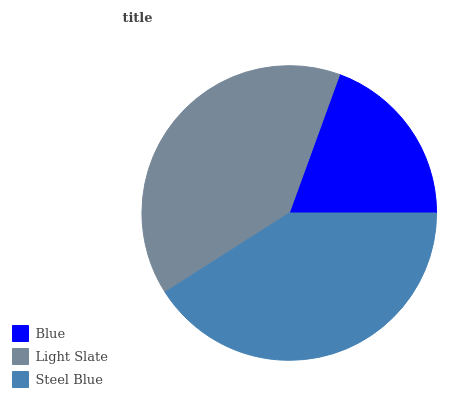Is Blue the minimum?
Answer yes or no. Yes. Is Steel Blue the maximum?
Answer yes or no. Yes. Is Light Slate the minimum?
Answer yes or no. No. Is Light Slate the maximum?
Answer yes or no. No. Is Light Slate greater than Blue?
Answer yes or no. Yes. Is Blue less than Light Slate?
Answer yes or no. Yes. Is Blue greater than Light Slate?
Answer yes or no. No. Is Light Slate less than Blue?
Answer yes or no. No. Is Light Slate the high median?
Answer yes or no. Yes. Is Light Slate the low median?
Answer yes or no. Yes. Is Blue the high median?
Answer yes or no. No. Is Steel Blue the low median?
Answer yes or no. No. 